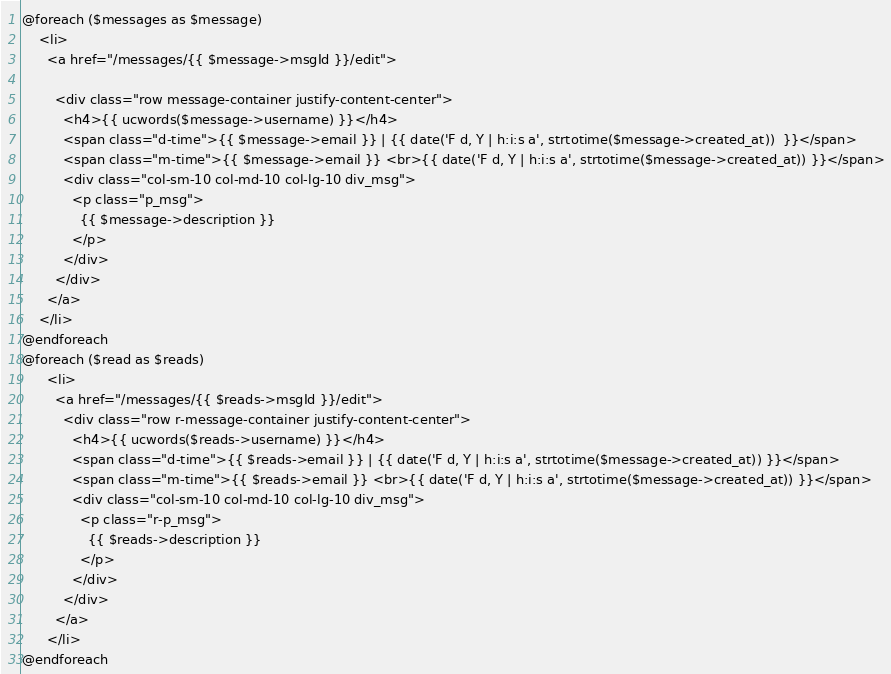Convert code to text. <code><loc_0><loc_0><loc_500><loc_500><_PHP_>@foreach ($messages as $message)
    <li>
      <a href="/messages/{{ $message->msgId }}/edit">

        <div class="row message-container justify-content-center">
          <h4>{{ ucwords($message->username) }}</h4>
          <span class="d-time">{{ $message->email }} | {{ date('F d, Y | h:i:s a', strtotime($message->created_at))  }}</span>
          <span class="m-time">{{ $message->email }} <br>{{ date('F d, Y | h:i:s a', strtotime($message->created_at)) }}</span>
          <div class="col-sm-10 col-md-10 col-lg-10 div_msg">
            <p class="p_msg">
              {{ $message->description }}
            </p>
          </div>
        </div>
      </a>
    </li>
@endforeach
@foreach ($read as $reads)
      <li>
        <a href="/messages/{{ $reads->msgId }}/edit">
          <div class="row r-message-container justify-content-center">
            <h4>{{ ucwords($reads->username) }}</h4>
            <span class="d-time">{{ $reads->email }} | {{ date('F d, Y | h:i:s a', strtotime($message->created_at)) }}</span>
            <span class="m-time">{{ $reads->email }} <br>{{ date('F d, Y | h:i:s a', strtotime($message->created_at)) }}</span>
            <div class="col-sm-10 col-md-10 col-lg-10 div_msg">
              <p class="r-p_msg">
                {{ $reads->description }}
              </p>
            </div>
          </div>
        </a>
      </li>
@endforeach
</code> 